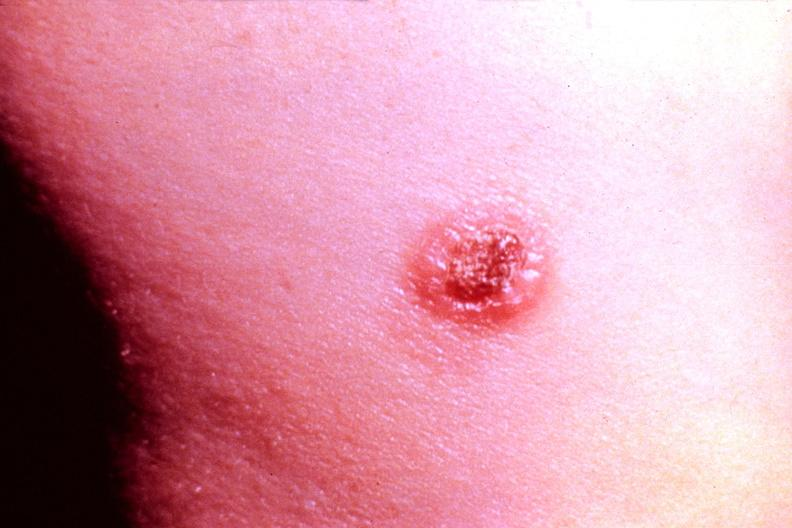does newborn cord around neck show cryptococcal dematitis?
Answer the question using a single word or phrase. No 